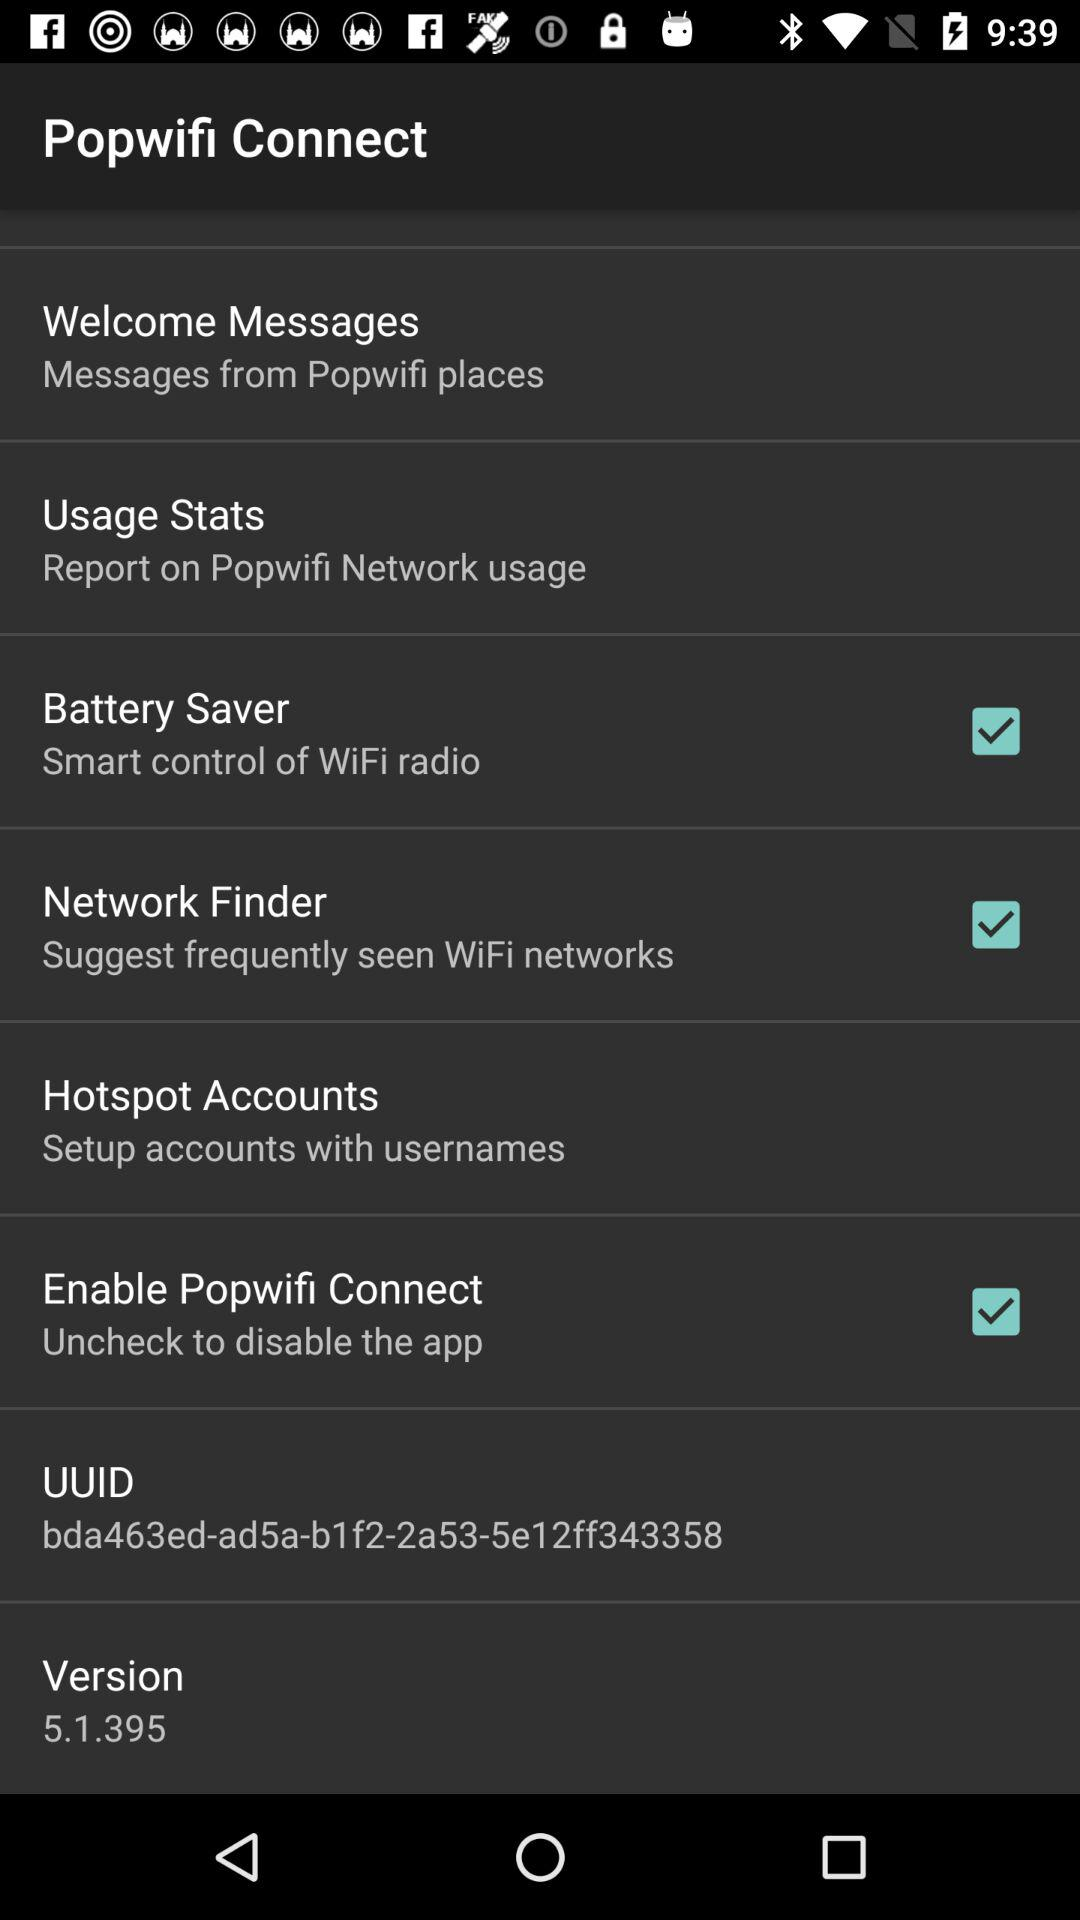What is the status of "Network Finder"? The status is "on". 